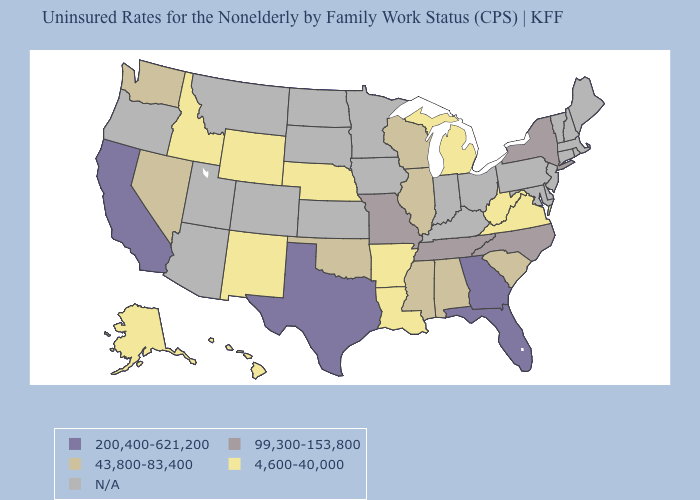What is the value of Wyoming?
Concise answer only. 4,600-40,000. Name the states that have a value in the range N/A?
Concise answer only. Arizona, Colorado, Connecticut, Delaware, Indiana, Iowa, Kansas, Kentucky, Maine, Maryland, Massachusetts, Minnesota, Montana, New Hampshire, New Jersey, North Dakota, Ohio, Oregon, Pennsylvania, Rhode Island, South Dakota, Utah, Vermont. Which states hav the highest value in the MidWest?
Give a very brief answer. Missouri. What is the value of Georgia?
Write a very short answer. 200,400-621,200. Name the states that have a value in the range 43,800-83,400?
Answer briefly. Alabama, Illinois, Mississippi, Nevada, Oklahoma, South Carolina, Washington, Wisconsin. Name the states that have a value in the range 43,800-83,400?
Short answer required. Alabama, Illinois, Mississippi, Nevada, Oklahoma, South Carolina, Washington, Wisconsin. How many symbols are there in the legend?
Keep it brief. 5. How many symbols are there in the legend?
Concise answer only. 5. Name the states that have a value in the range 43,800-83,400?
Write a very short answer. Alabama, Illinois, Mississippi, Nevada, Oklahoma, South Carolina, Washington, Wisconsin. Does the map have missing data?
Quick response, please. Yes. What is the highest value in states that border Massachusetts?
Answer briefly. 99,300-153,800. Name the states that have a value in the range 99,300-153,800?
Concise answer only. Missouri, New York, North Carolina, Tennessee. What is the value of Louisiana?
Keep it brief. 4,600-40,000. 